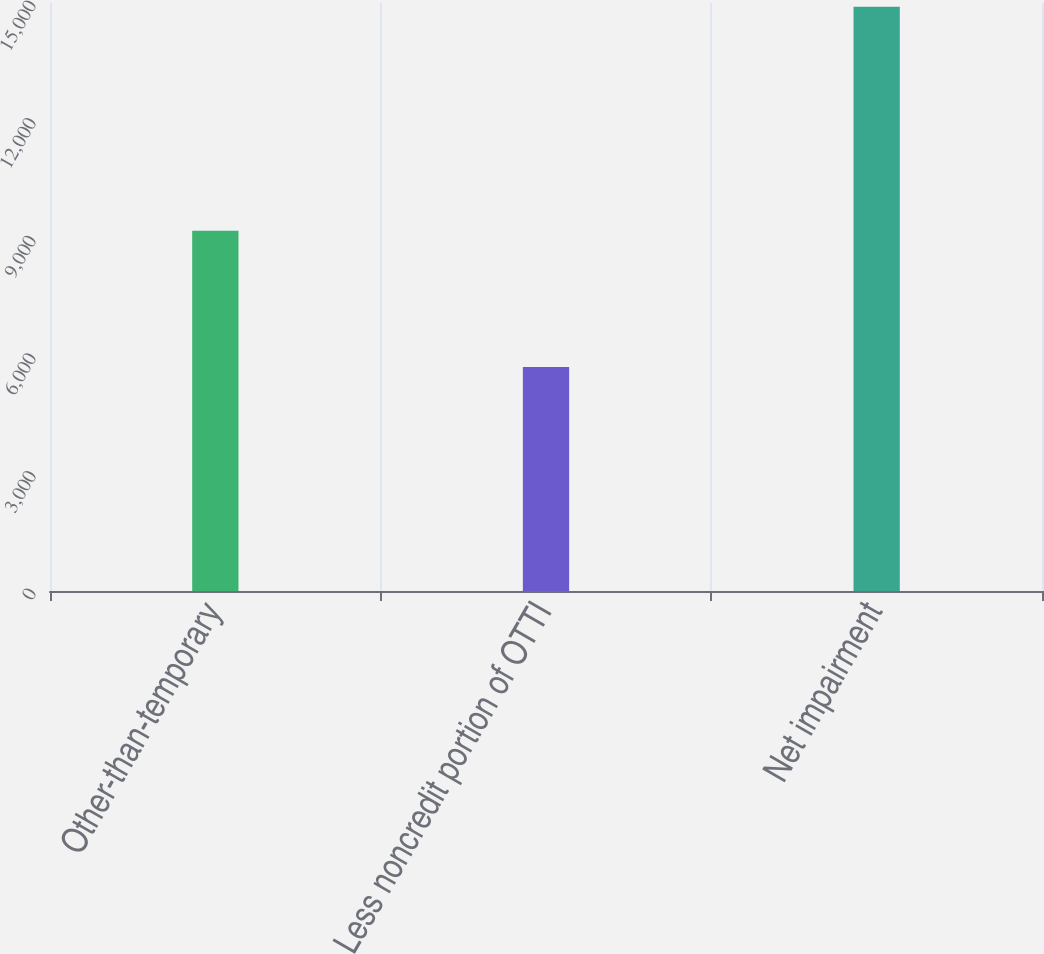Convert chart to OTSL. <chart><loc_0><loc_0><loc_500><loc_500><bar_chart><fcel>Other-than-temporary<fcel>Less noncredit portion of OTTI<fcel>Net impairment<nl><fcel>9190<fcel>5717<fcel>14907<nl></chart> 